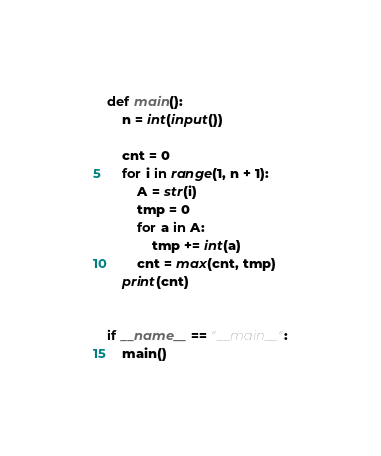Convert code to text. <code><loc_0><loc_0><loc_500><loc_500><_Python_>def main():
    n = int(input())
    
    cnt = 0
    for i in range(1, n + 1):
        A = str(i)
        tmp = 0
        for a in A:
            tmp += int(a)
        cnt = max(cnt, tmp)
    print(cnt)


if __name__ == "__main__":
    main()</code> 